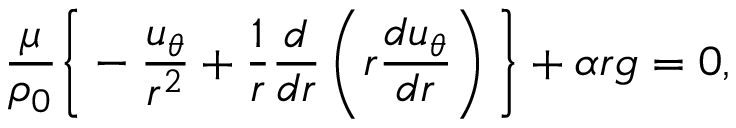<formula> <loc_0><loc_0><loc_500><loc_500>\frac { \mu } { \rho _ { 0 } } \left \{ - \frac { u _ { \theta } } { r ^ { 2 } } + \frac { 1 } { r } \frac { d } { d r } \left ( r \frac { d u _ { \theta } } { d r } \right ) \right \} + \alpha r g = 0 ,</formula> 